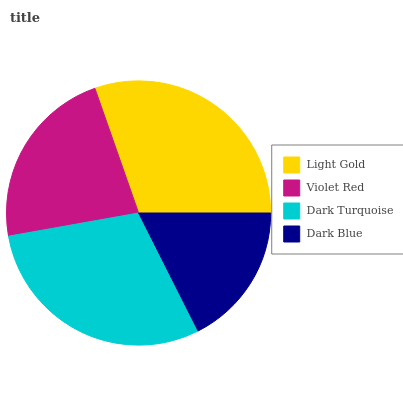Is Dark Blue the minimum?
Answer yes or no. Yes. Is Light Gold the maximum?
Answer yes or no. Yes. Is Violet Red the minimum?
Answer yes or no. No. Is Violet Red the maximum?
Answer yes or no. No. Is Light Gold greater than Violet Red?
Answer yes or no. Yes. Is Violet Red less than Light Gold?
Answer yes or no. Yes. Is Violet Red greater than Light Gold?
Answer yes or no. No. Is Light Gold less than Violet Red?
Answer yes or no. No. Is Dark Turquoise the high median?
Answer yes or no. Yes. Is Violet Red the low median?
Answer yes or no. Yes. Is Dark Blue the high median?
Answer yes or no. No. Is Light Gold the low median?
Answer yes or no. No. 